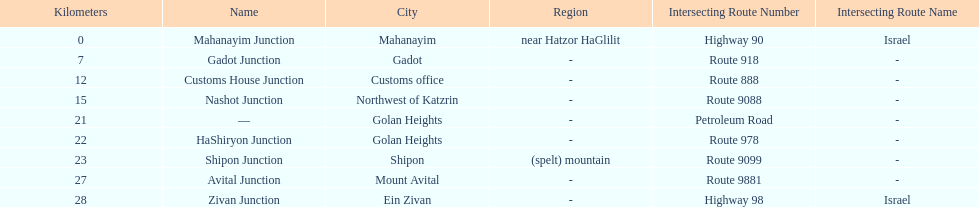Which junction on highway 91 is closer to ein zivan, gadot junction or shipon junction? Gadot Junction. 